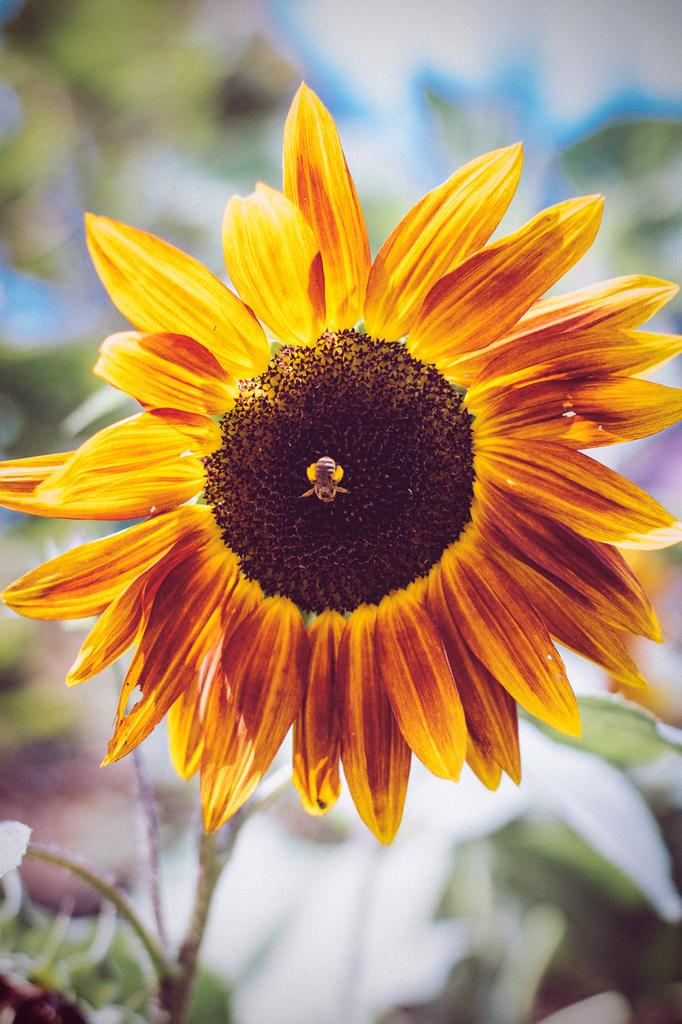What type of flower is in the image? There is a yellow flower in the image. Is there any wildlife interacting with the flower? Yes, a honey bee is on the flower. What can be seen in the background of the image? There are plants or trees in the background of the image. How is the background of the image depicted? The background of the image is blurred. How many feet does the daughter have in the image? There is no daughter present in the image, so it is not possible to determine the number of feet she might have. 